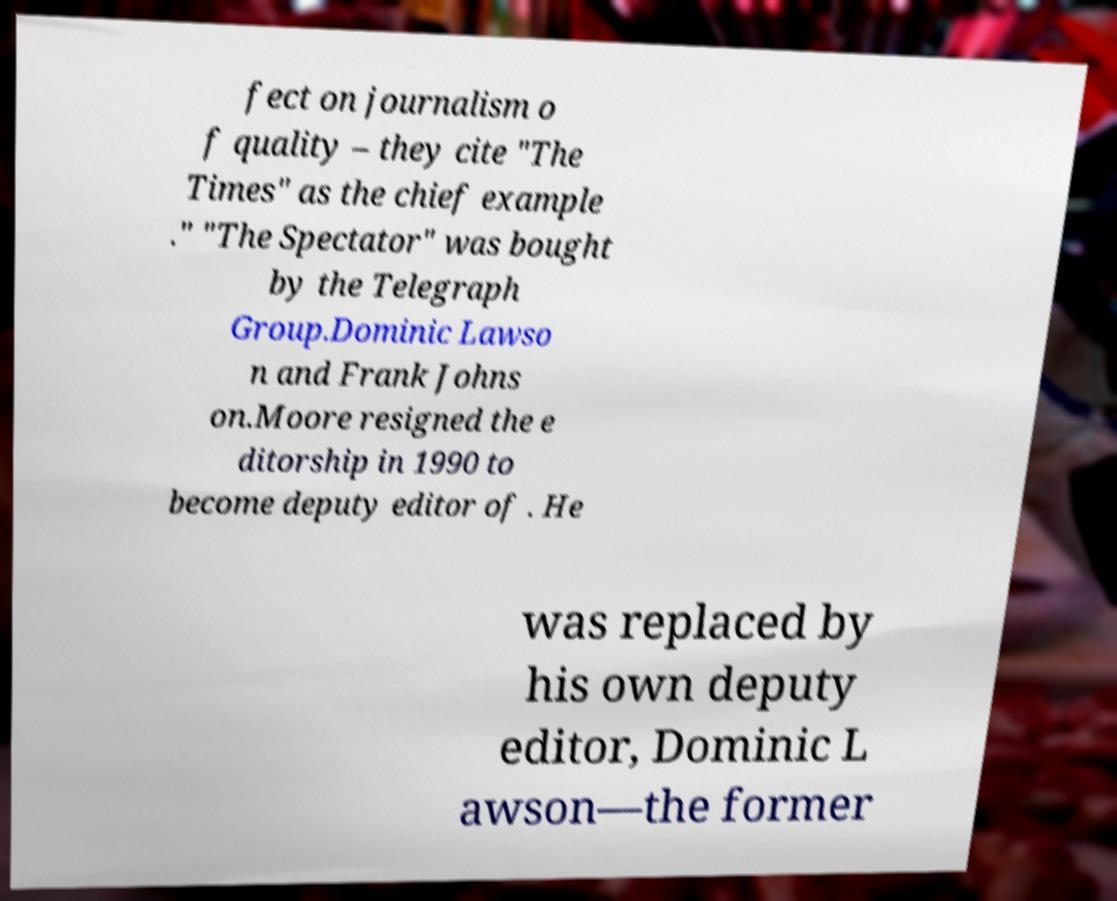Can you accurately transcribe the text from the provided image for me? fect on journalism o f quality – they cite "The Times" as the chief example ." "The Spectator" was bought by the Telegraph Group.Dominic Lawso n and Frank Johns on.Moore resigned the e ditorship in 1990 to become deputy editor of . He was replaced by his own deputy editor, Dominic L awson—the former 